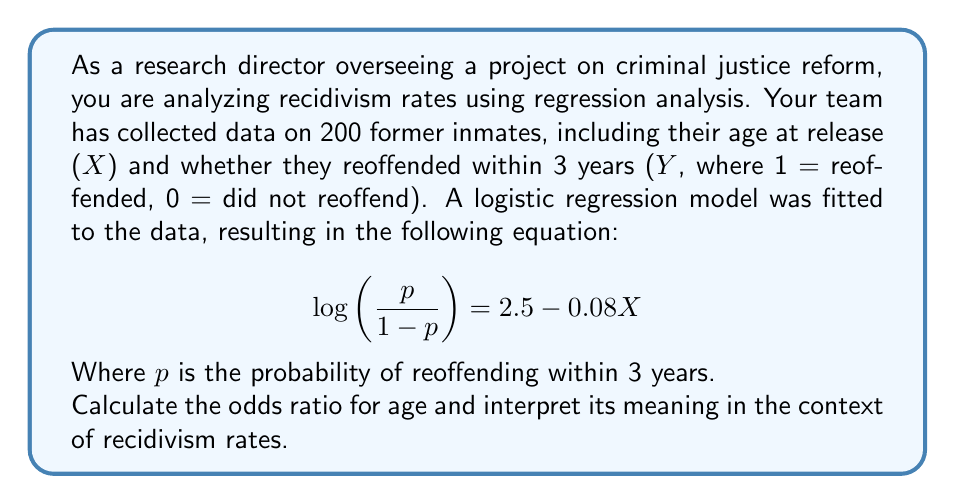Solve this math problem. To solve this problem, we need to follow these steps:

1. Understand the logistic regression equation:
   The equation $\log\left(\frac{p}{1-p}\right) = 2.5 - 0.08X$ represents the log-odds of reoffending as a function of age.

2. Identify the coefficient for age:
   The coefficient for age (X) is -0.08.

3. Calculate the odds ratio:
   The odds ratio is the exponential of the coefficient.
   $$ \text{Odds Ratio} = e^{-0.08} $$

4. Compute the odds ratio:
   $$ \text{Odds Ratio} = e^{-0.08} \approx 0.9231 $$

5. Interpret the odds ratio:
   An odds ratio less than 1 indicates that as age increases, the odds of reoffending decrease.
   Specifically, for each one-year increase in age, the odds of reoffending are multiplied by 0.9231.

   We can also express this as a percentage change:
   $$ \text{Percentage Change} = (0.9231 - 1) \times 100\% = -7.69\% $$

   This means that for each one-year increase in age, the odds of reoffending decrease by approximately 7.69%.
Answer: The odds ratio for age is approximately 0.9231. This means that for each one-year increase in age at release, the odds of reoffending within 3 years decrease by about 7.69%, holding other factors constant. 